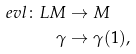<formula> <loc_0><loc_0><loc_500><loc_500>\ e v l \colon L M & \to M \\ \gamma & \to \gamma ( 1 ) ,</formula> 